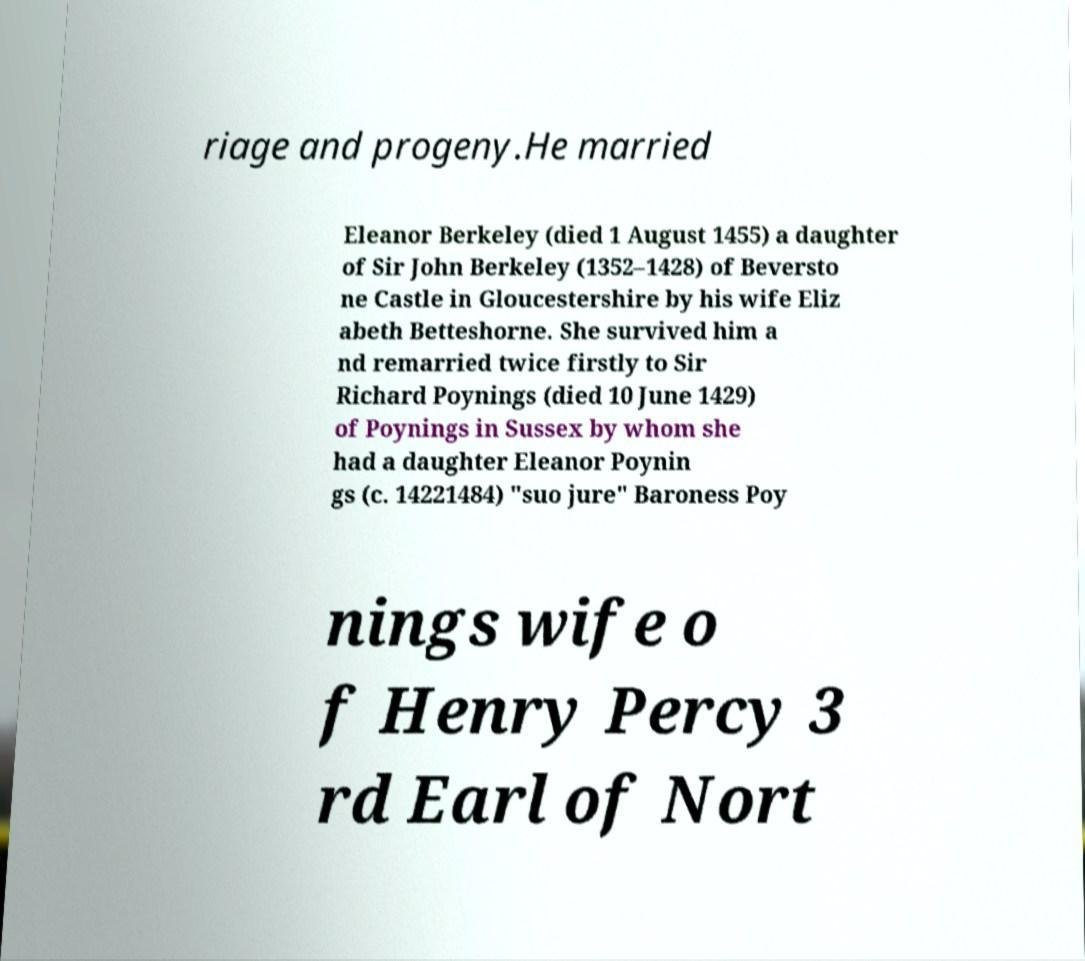Could you extract and type out the text from this image? riage and progeny.He married Eleanor Berkeley (died 1 August 1455) a daughter of Sir John Berkeley (1352–1428) of Beversto ne Castle in Gloucestershire by his wife Eliz abeth Betteshorne. She survived him a nd remarried twice firstly to Sir Richard Poynings (died 10 June 1429) of Poynings in Sussex by whom she had a daughter Eleanor Poynin gs (c. 14221484) "suo jure" Baroness Poy nings wife o f Henry Percy 3 rd Earl of Nort 